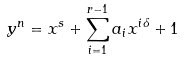<formula> <loc_0><loc_0><loc_500><loc_500>y ^ { n } = x ^ { s } + \sum _ { i = 1 } ^ { r - 1 } a _ { i } x ^ { i \delta } + 1</formula> 